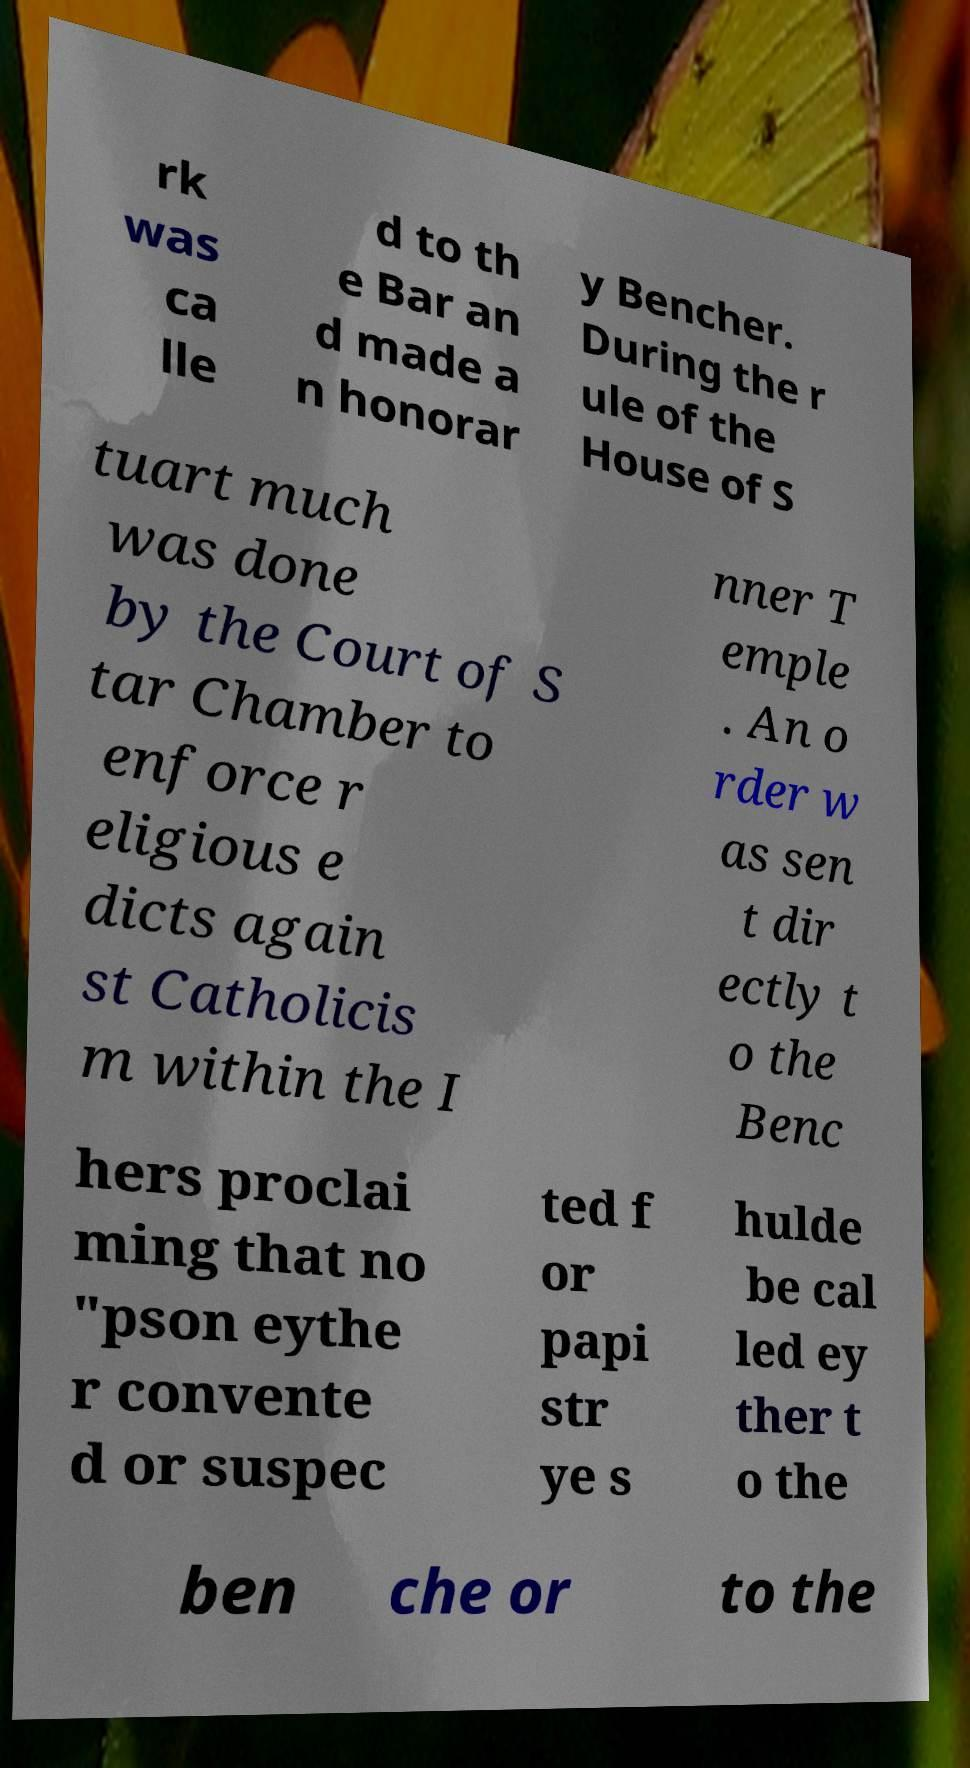For documentation purposes, I need the text within this image transcribed. Could you provide that? rk was ca lle d to th e Bar an d made a n honorar y Bencher. During the r ule of the House of S tuart much was done by the Court of S tar Chamber to enforce r eligious e dicts again st Catholicis m within the I nner T emple . An o rder w as sen t dir ectly t o the Benc hers proclai ming that no "pson eythe r convente d or suspec ted f or papi str ye s hulde be cal led ey ther t o the ben che or to the 